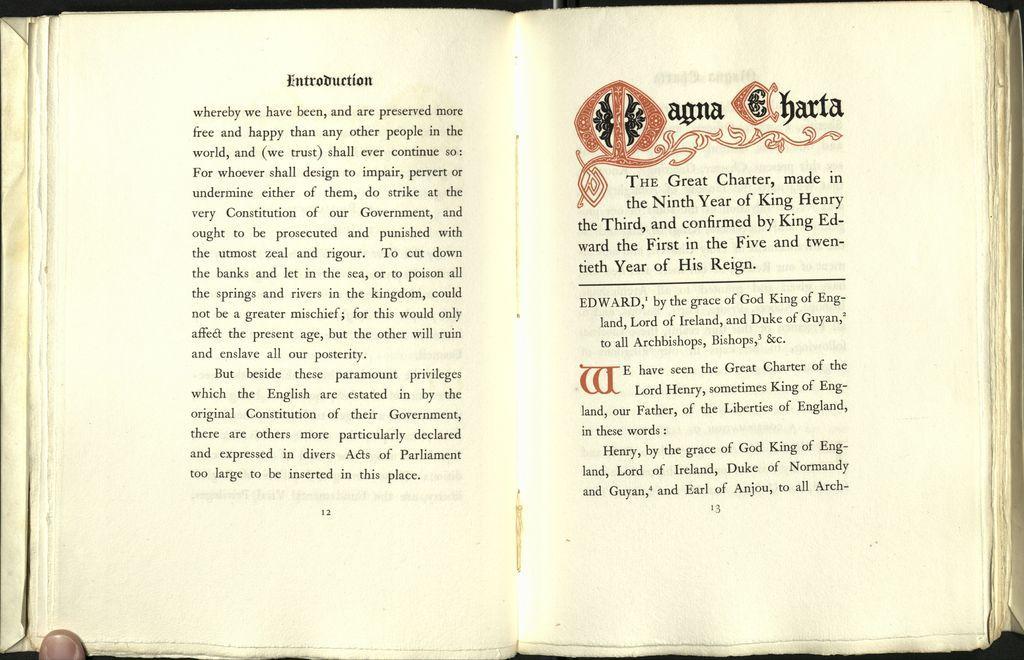Please provide a concise description of this image. In this image we can see a book, here is the page, there is some matter written on it. 